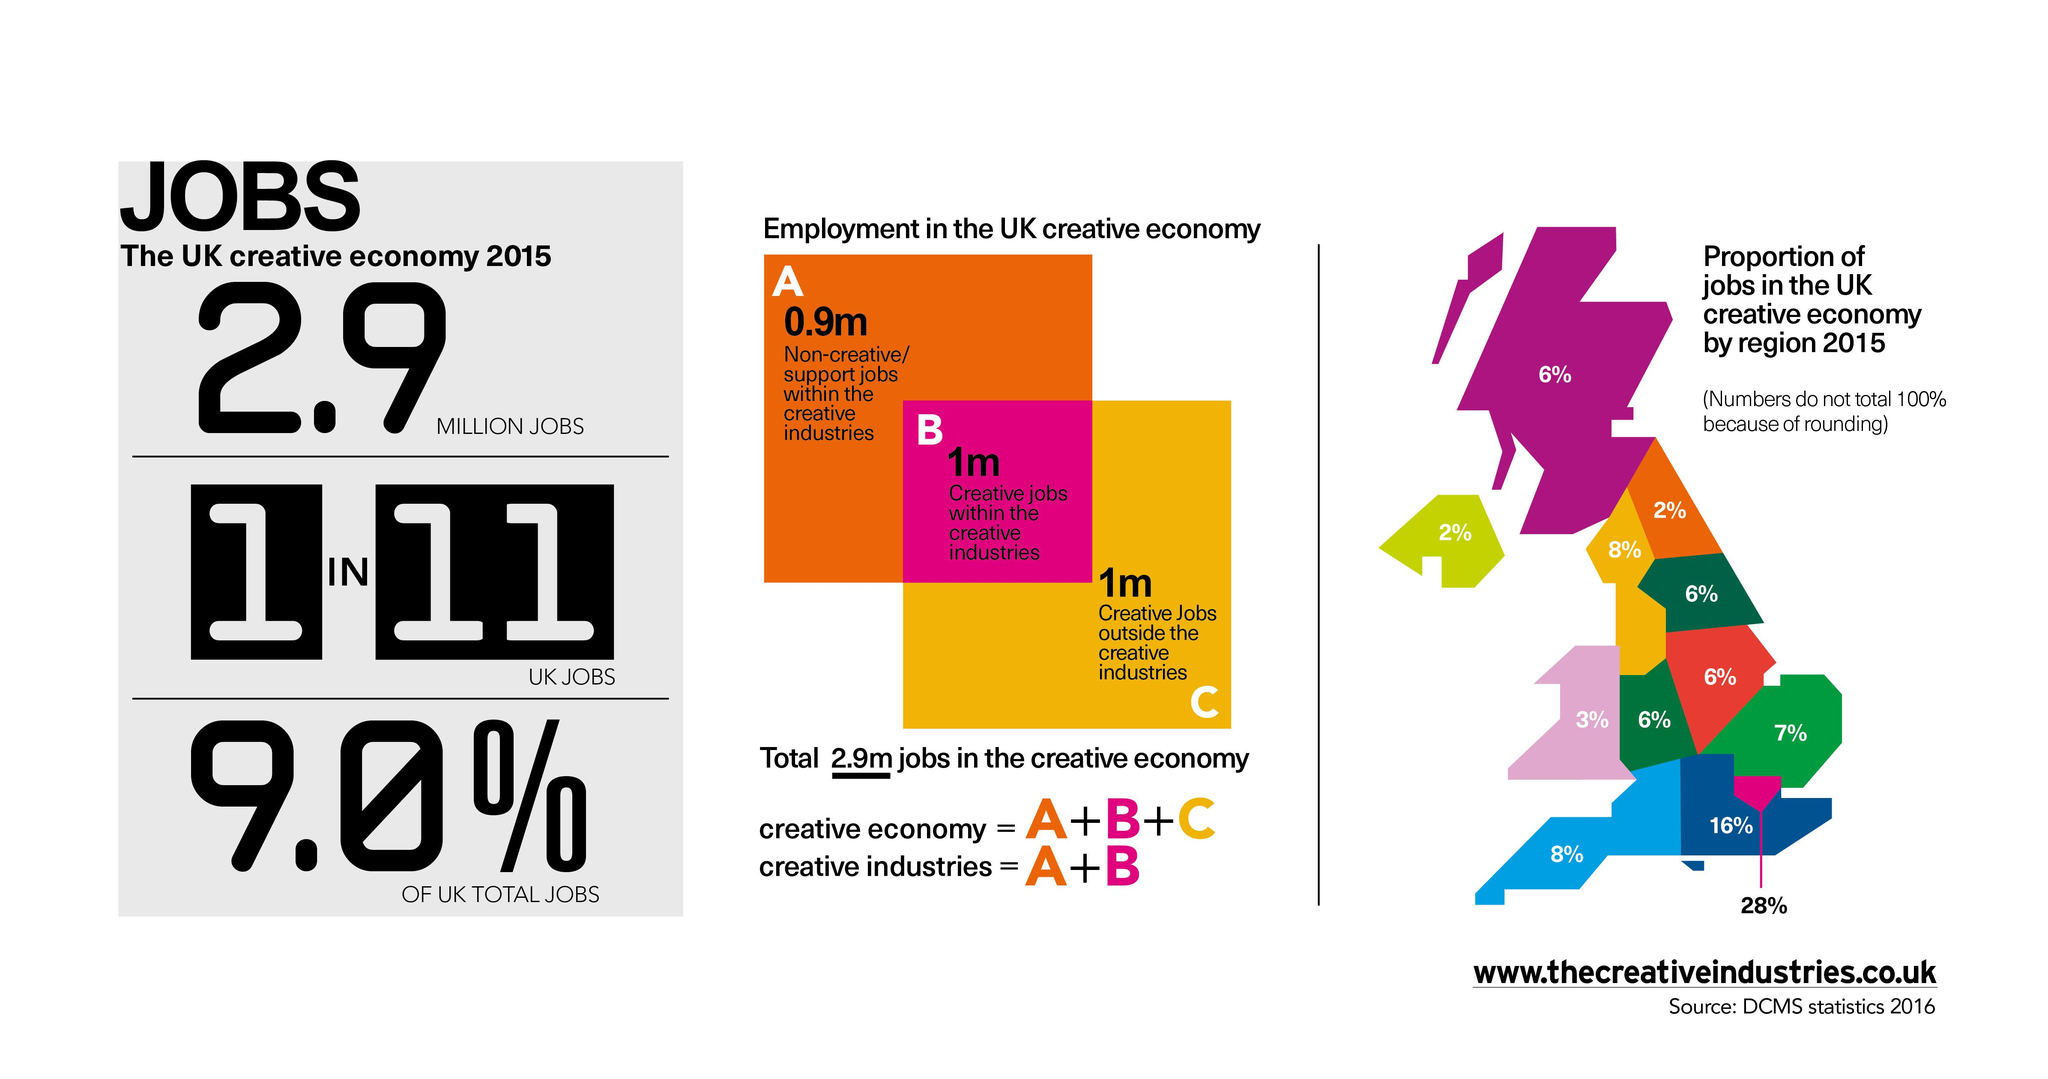Identify some key points in this picture. According to recent data, the creative industry employs approximately 1.9 million workers in total. The letter A represents non-creative/support jobs within creative industries. The non-creative industry has a total of millions of jobs. According to a recent study, approximately 9% of jobs in the UK fall within the creative economy. The letter "C" in the middle graphic represents creative jobs outside of the creative industries, such as jobs in fields like technology, education, and healthcare that require creative problem-solving skills. 